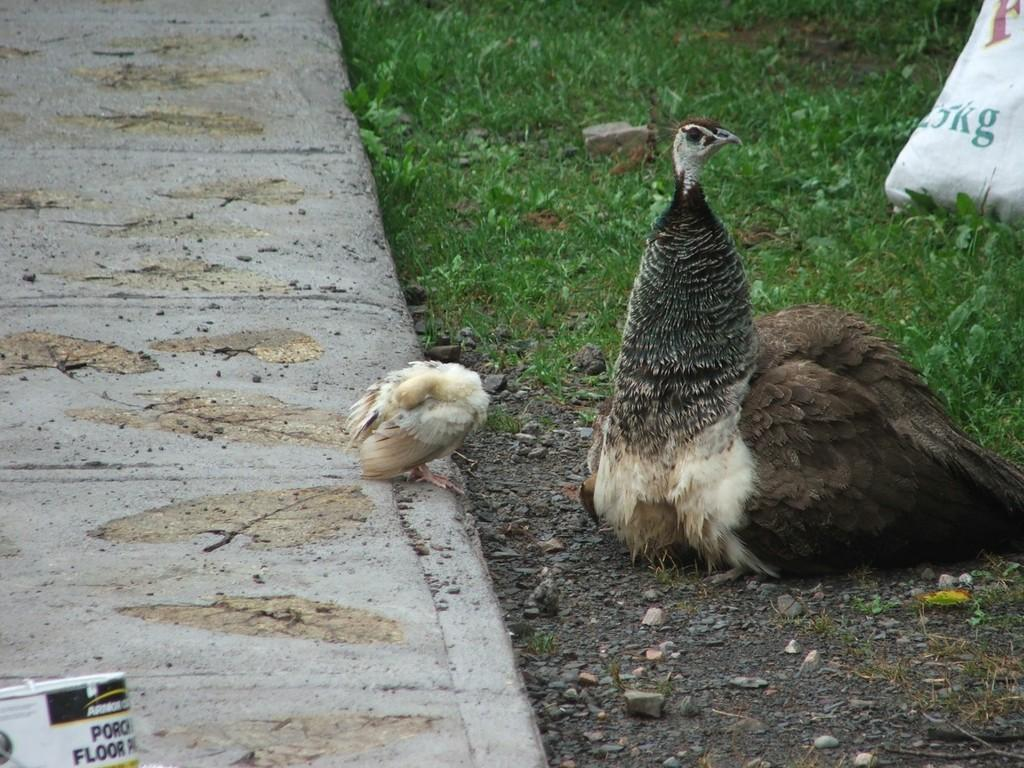What type of animal is in the image? There is a peacock in the image. What can be seen in the background of the image? There is grass and a path in the background of the image. How many basketballs can be seen in the image? There are no basketballs present in the image. 